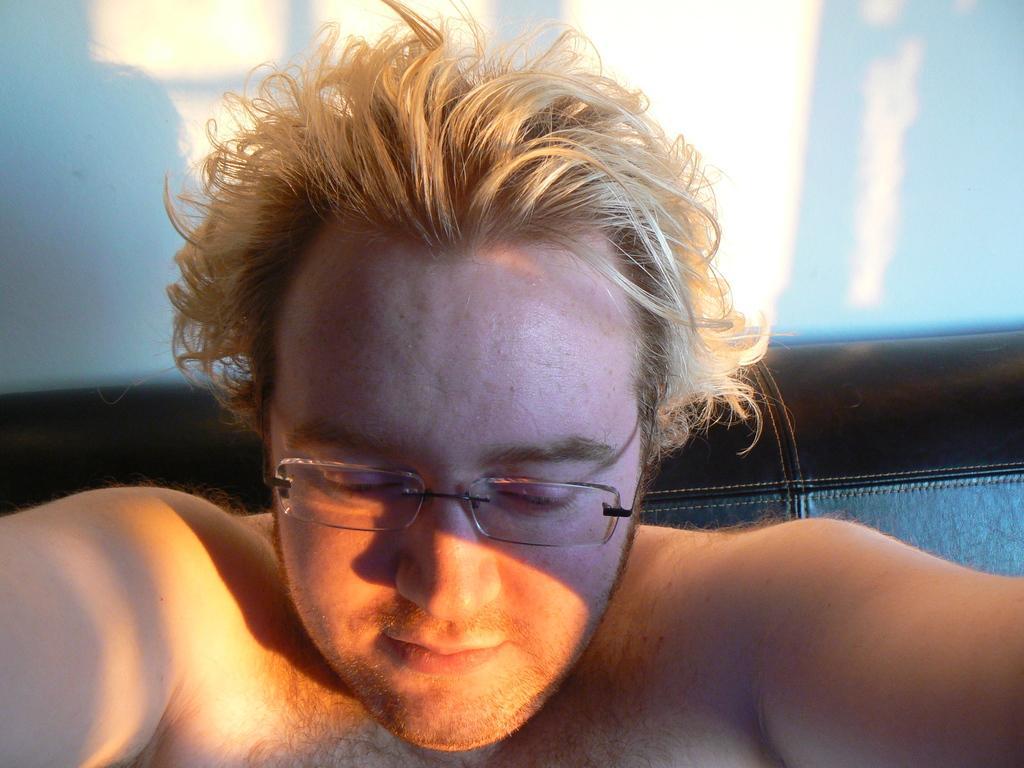Can you describe this image briefly? In this image we can see a man wearing specs. In the back there is a wall. 